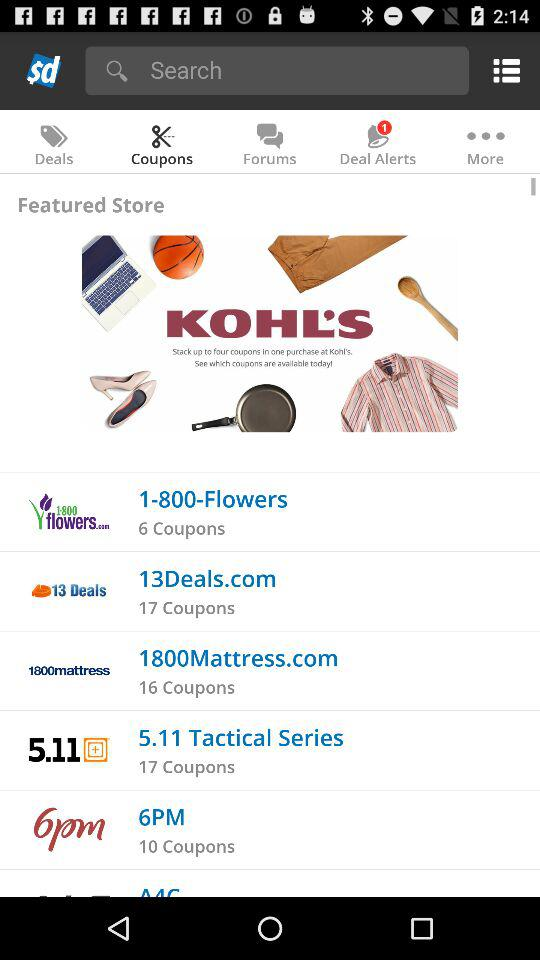What is the number of coupons in 13Deals.com? The number of coupons in 13Deals.com is 17. 